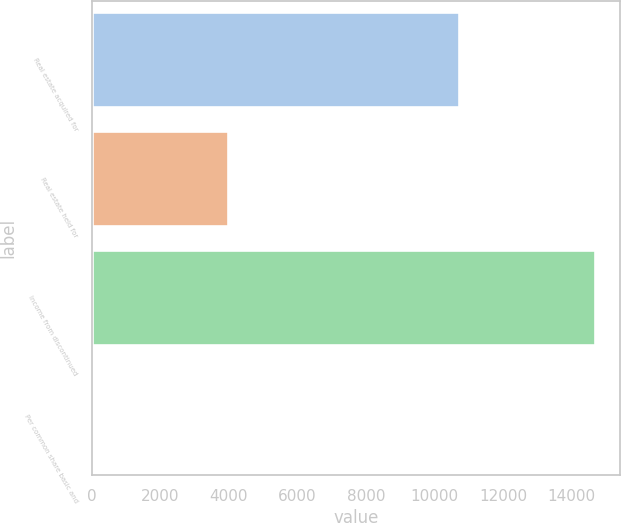Convert chart to OTSL. <chart><loc_0><loc_0><loc_500><loc_500><bar_chart><fcel>Real estate acquired for<fcel>Real estate held for<fcel>Income from discontinued<fcel>Per common share basic and<nl><fcel>10703<fcel>3963<fcel>14666<fcel>0.15<nl></chart> 